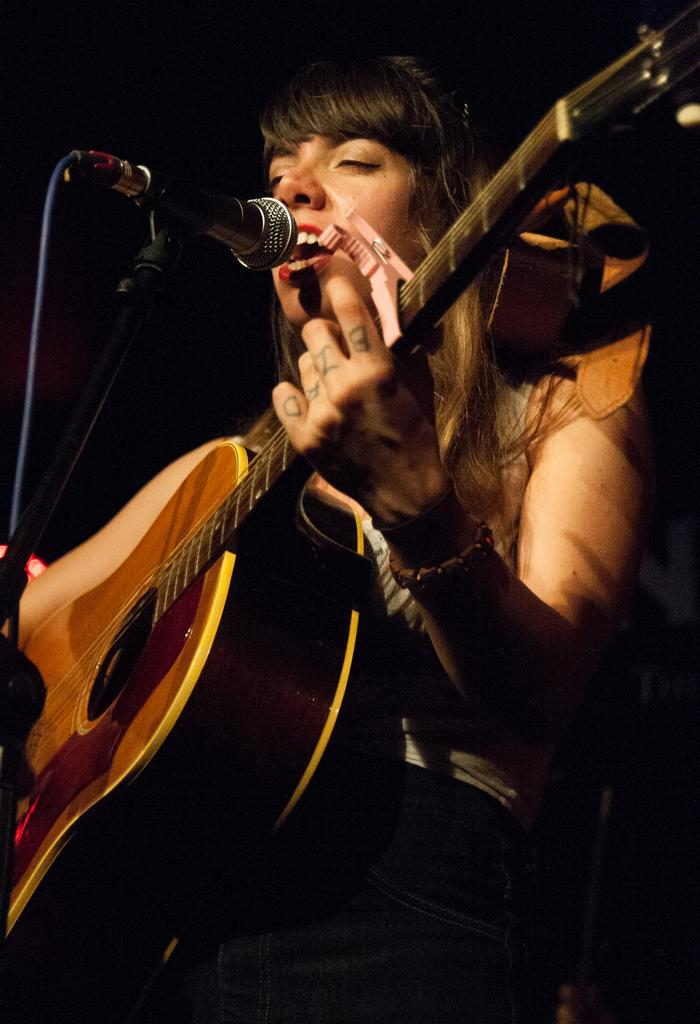Who is the main subject in the image? There is a lady in the image. What is the lady holding in the image? The lady is holding a guitar. What is the lady doing in the image? The lady is singing. What is in front of the lady that might be used for amplifying her voice? There is a microphone in front of the lady. Are there any cobwebs visible in the image? There is no mention of cobwebs in the provided facts, so we cannot determine if any are present in the image. 